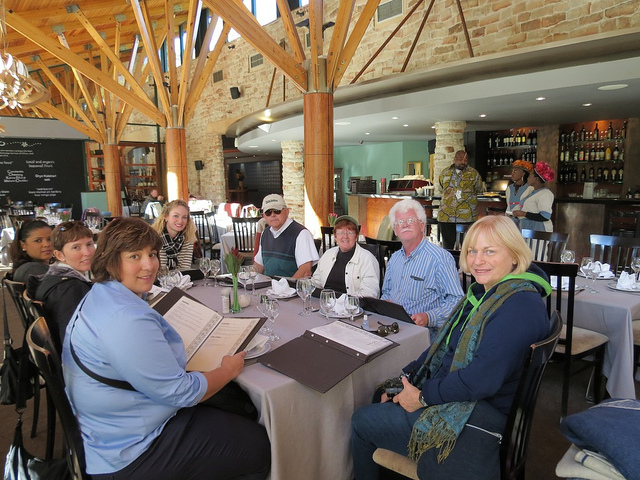Can you tell me about the lighting and overall mood of the setting? The setting has abundant natural light streaming from the windows, creating a bright and welcoming mood. The wooden ceiling beams add warmth and a rustic charm to the overall ambiance. Does the lighting seem appropriate for dining? Yes, the natural lighting complemented by the indoor fixtures provides a pleasant dining experience, illuminating the space without being harsh or glaring. 